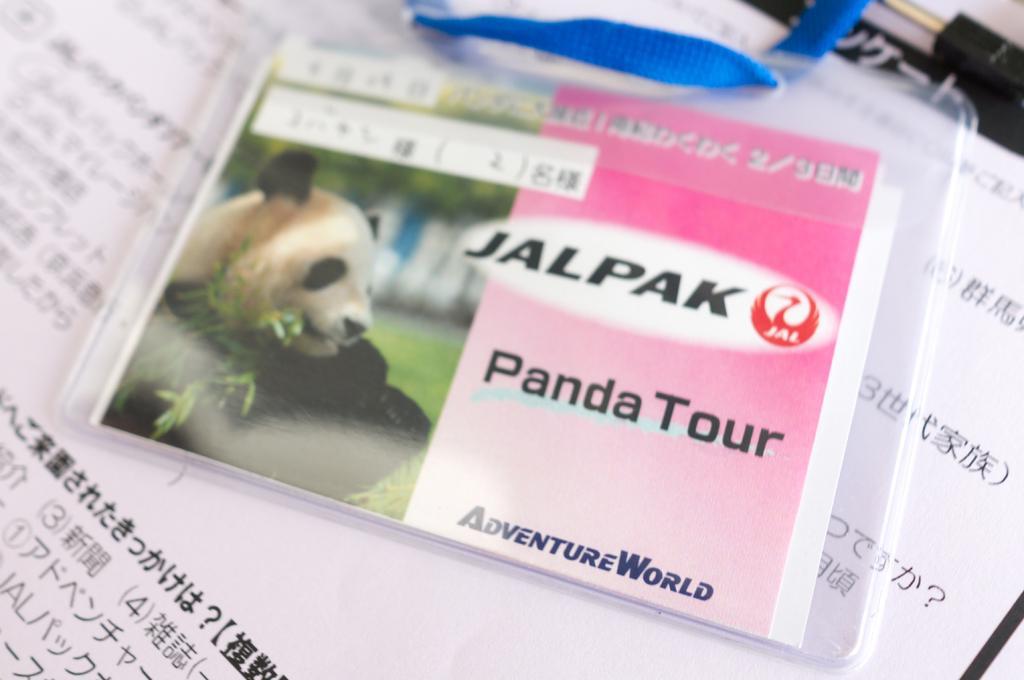In one or two sentences, can you explain what this image depicts? In this picture we can see tag with card on a paper, on this card we can see image of a panda. 